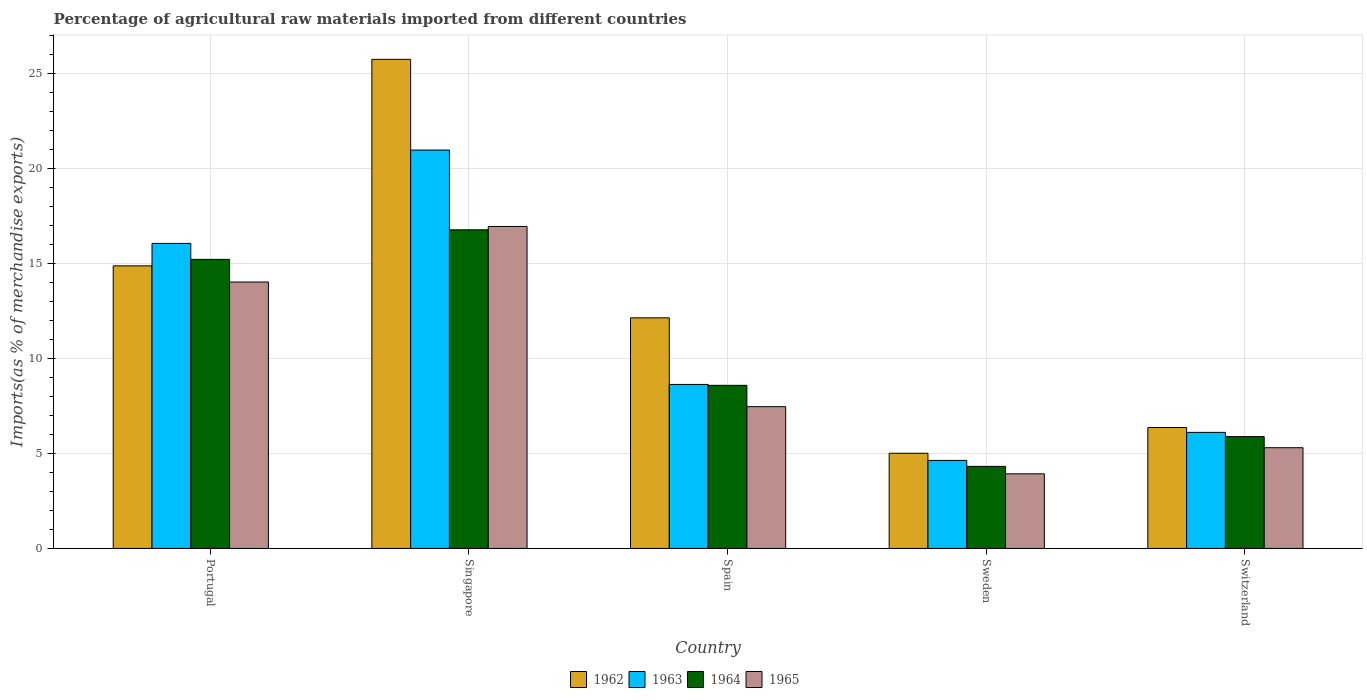How many different coloured bars are there?
Keep it short and to the point. 4. Are the number of bars per tick equal to the number of legend labels?
Your answer should be compact. Yes. How many bars are there on the 2nd tick from the left?
Your response must be concise. 4. What is the percentage of imports to different countries in 1963 in Spain?
Your answer should be very brief. 8.63. Across all countries, what is the maximum percentage of imports to different countries in 1963?
Provide a short and direct response. 20.95. Across all countries, what is the minimum percentage of imports to different countries in 1965?
Make the answer very short. 3.92. In which country was the percentage of imports to different countries in 1965 maximum?
Make the answer very short. Singapore. In which country was the percentage of imports to different countries in 1962 minimum?
Offer a terse response. Sweden. What is the total percentage of imports to different countries in 1962 in the graph?
Your answer should be very brief. 64.08. What is the difference between the percentage of imports to different countries in 1965 in Singapore and that in Switzerland?
Ensure brevity in your answer.  11.64. What is the difference between the percentage of imports to different countries in 1965 in Portugal and the percentage of imports to different countries in 1962 in Switzerland?
Your response must be concise. 7.65. What is the average percentage of imports to different countries in 1963 per country?
Give a very brief answer. 11.27. What is the difference between the percentage of imports to different countries of/in 1962 and percentage of imports to different countries of/in 1963 in Portugal?
Provide a short and direct response. -1.18. In how many countries, is the percentage of imports to different countries in 1965 greater than 15 %?
Offer a very short reply. 1. What is the ratio of the percentage of imports to different countries in 1963 in Singapore to that in Spain?
Make the answer very short. 2.43. Is the percentage of imports to different countries in 1964 in Sweden less than that in Switzerland?
Ensure brevity in your answer.  Yes. Is the difference between the percentage of imports to different countries in 1962 in Singapore and Switzerland greater than the difference between the percentage of imports to different countries in 1963 in Singapore and Switzerland?
Keep it short and to the point. Yes. What is the difference between the highest and the second highest percentage of imports to different countries in 1965?
Provide a succinct answer. 2.92. What is the difference between the highest and the lowest percentage of imports to different countries in 1962?
Keep it short and to the point. 20.72. Is the sum of the percentage of imports to different countries in 1965 in Spain and Sweden greater than the maximum percentage of imports to different countries in 1962 across all countries?
Provide a short and direct response. No. Is it the case that in every country, the sum of the percentage of imports to different countries in 1963 and percentage of imports to different countries in 1962 is greater than the sum of percentage of imports to different countries in 1964 and percentage of imports to different countries in 1965?
Make the answer very short. No. What does the 1st bar from the right in Sweden represents?
Your answer should be very brief. 1965. Are all the bars in the graph horizontal?
Keep it short and to the point. No. What is the difference between two consecutive major ticks on the Y-axis?
Offer a terse response. 5. Does the graph contain any zero values?
Make the answer very short. No. How are the legend labels stacked?
Your answer should be very brief. Horizontal. What is the title of the graph?
Offer a very short reply. Percentage of agricultural raw materials imported from different countries. What is the label or title of the X-axis?
Offer a very short reply. Country. What is the label or title of the Y-axis?
Give a very brief answer. Imports(as % of merchandise exports). What is the Imports(as % of merchandise exports) in 1962 in Portugal?
Provide a short and direct response. 14.86. What is the Imports(as % of merchandise exports) in 1963 in Portugal?
Your answer should be very brief. 16.04. What is the Imports(as % of merchandise exports) of 1964 in Portugal?
Give a very brief answer. 15.2. What is the Imports(as % of merchandise exports) of 1965 in Portugal?
Keep it short and to the point. 14.01. What is the Imports(as % of merchandise exports) in 1962 in Singapore?
Keep it short and to the point. 25.73. What is the Imports(as % of merchandise exports) of 1963 in Singapore?
Ensure brevity in your answer.  20.95. What is the Imports(as % of merchandise exports) in 1964 in Singapore?
Make the answer very short. 16.76. What is the Imports(as % of merchandise exports) in 1965 in Singapore?
Offer a very short reply. 16.93. What is the Imports(as % of merchandise exports) of 1962 in Spain?
Give a very brief answer. 12.13. What is the Imports(as % of merchandise exports) of 1963 in Spain?
Your answer should be compact. 8.63. What is the Imports(as % of merchandise exports) of 1964 in Spain?
Your answer should be compact. 8.58. What is the Imports(as % of merchandise exports) in 1965 in Spain?
Offer a very short reply. 7.46. What is the Imports(as % of merchandise exports) of 1962 in Sweden?
Offer a terse response. 5.01. What is the Imports(as % of merchandise exports) in 1963 in Sweden?
Offer a very short reply. 4.63. What is the Imports(as % of merchandise exports) of 1964 in Sweden?
Provide a succinct answer. 4.32. What is the Imports(as % of merchandise exports) in 1965 in Sweden?
Offer a very short reply. 3.92. What is the Imports(as % of merchandise exports) in 1962 in Switzerland?
Ensure brevity in your answer.  6.36. What is the Imports(as % of merchandise exports) in 1963 in Switzerland?
Offer a very short reply. 6.1. What is the Imports(as % of merchandise exports) in 1964 in Switzerland?
Your answer should be very brief. 5.88. What is the Imports(as % of merchandise exports) of 1965 in Switzerland?
Give a very brief answer. 5.3. Across all countries, what is the maximum Imports(as % of merchandise exports) in 1962?
Keep it short and to the point. 25.73. Across all countries, what is the maximum Imports(as % of merchandise exports) in 1963?
Offer a very short reply. 20.95. Across all countries, what is the maximum Imports(as % of merchandise exports) of 1964?
Provide a short and direct response. 16.76. Across all countries, what is the maximum Imports(as % of merchandise exports) in 1965?
Ensure brevity in your answer.  16.93. Across all countries, what is the minimum Imports(as % of merchandise exports) in 1962?
Provide a short and direct response. 5.01. Across all countries, what is the minimum Imports(as % of merchandise exports) of 1963?
Offer a terse response. 4.63. Across all countries, what is the minimum Imports(as % of merchandise exports) of 1964?
Offer a very short reply. 4.32. Across all countries, what is the minimum Imports(as % of merchandise exports) of 1965?
Your answer should be compact. 3.92. What is the total Imports(as % of merchandise exports) of 1962 in the graph?
Offer a very short reply. 64.08. What is the total Imports(as % of merchandise exports) in 1963 in the graph?
Provide a short and direct response. 56.36. What is the total Imports(as % of merchandise exports) of 1964 in the graph?
Provide a succinct answer. 50.74. What is the total Imports(as % of merchandise exports) in 1965 in the graph?
Ensure brevity in your answer.  47.63. What is the difference between the Imports(as % of merchandise exports) of 1962 in Portugal and that in Singapore?
Your answer should be very brief. -10.86. What is the difference between the Imports(as % of merchandise exports) in 1963 in Portugal and that in Singapore?
Offer a very short reply. -4.91. What is the difference between the Imports(as % of merchandise exports) in 1964 in Portugal and that in Singapore?
Offer a terse response. -1.55. What is the difference between the Imports(as % of merchandise exports) of 1965 in Portugal and that in Singapore?
Your answer should be very brief. -2.92. What is the difference between the Imports(as % of merchandise exports) in 1962 in Portugal and that in Spain?
Your answer should be very brief. 2.73. What is the difference between the Imports(as % of merchandise exports) in 1963 in Portugal and that in Spain?
Make the answer very short. 7.42. What is the difference between the Imports(as % of merchandise exports) of 1964 in Portugal and that in Spain?
Ensure brevity in your answer.  6.63. What is the difference between the Imports(as % of merchandise exports) of 1965 in Portugal and that in Spain?
Your response must be concise. 6.56. What is the difference between the Imports(as % of merchandise exports) of 1962 in Portugal and that in Sweden?
Keep it short and to the point. 9.86. What is the difference between the Imports(as % of merchandise exports) in 1963 in Portugal and that in Sweden?
Ensure brevity in your answer.  11.41. What is the difference between the Imports(as % of merchandise exports) of 1964 in Portugal and that in Sweden?
Offer a terse response. 10.89. What is the difference between the Imports(as % of merchandise exports) in 1965 in Portugal and that in Sweden?
Your answer should be very brief. 10.09. What is the difference between the Imports(as % of merchandise exports) in 1962 in Portugal and that in Switzerland?
Ensure brevity in your answer.  8.5. What is the difference between the Imports(as % of merchandise exports) in 1963 in Portugal and that in Switzerland?
Your response must be concise. 9.94. What is the difference between the Imports(as % of merchandise exports) in 1964 in Portugal and that in Switzerland?
Offer a very short reply. 9.32. What is the difference between the Imports(as % of merchandise exports) of 1965 in Portugal and that in Switzerland?
Provide a short and direct response. 8.72. What is the difference between the Imports(as % of merchandise exports) of 1962 in Singapore and that in Spain?
Ensure brevity in your answer.  13.6. What is the difference between the Imports(as % of merchandise exports) in 1963 in Singapore and that in Spain?
Provide a short and direct response. 12.33. What is the difference between the Imports(as % of merchandise exports) of 1964 in Singapore and that in Spain?
Your response must be concise. 8.18. What is the difference between the Imports(as % of merchandise exports) in 1965 in Singapore and that in Spain?
Ensure brevity in your answer.  9.48. What is the difference between the Imports(as % of merchandise exports) in 1962 in Singapore and that in Sweden?
Provide a succinct answer. 20.72. What is the difference between the Imports(as % of merchandise exports) in 1963 in Singapore and that in Sweden?
Provide a succinct answer. 16.32. What is the difference between the Imports(as % of merchandise exports) in 1964 in Singapore and that in Sweden?
Keep it short and to the point. 12.44. What is the difference between the Imports(as % of merchandise exports) of 1965 in Singapore and that in Sweden?
Your answer should be compact. 13.01. What is the difference between the Imports(as % of merchandise exports) in 1962 in Singapore and that in Switzerland?
Offer a very short reply. 19.37. What is the difference between the Imports(as % of merchandise exports) in 1963 in Singapore and that in Switzerland?
Your response must be concise. 14.85. What is the difference between the Imports(as % of merchandise exports) in 1964 in Singapore and that in Switzerland?
Ensure brevity in your answer.  10.88. What is the difference between the Imports(as % of merchandise exports) of 1965 in Singapore and that in Switzerland?
Provide a succinct answer. 11.64. What is the difference between the Imports(as % of merchandise exports) in 1962 in Spain and that in Sweden?
Provide a succinct answer. 7.12. What is the difference between the Imports(as % of merchandise exports) of 1963 in Spain and that in Sweden?
Make the answer very short. 4. What is the difference between the Imports(as % of merchandise exports) in 1964 in Spain and that in Sweden?
Your response must be concise. 4.26. What is the difference between the Imports(as % of merchandise exports) of 1965 in Spain and that in Sweden?
Provide a short and direct response. 3.53. What is the difference between the Imports(as % of merchandise exports) of 1962 in Spain and that in Switzerland?
Give a very brief answer. 5.77. What is the difference between the Imports(as % of merchandise exports) in 1963 in Spain and that in Switzerland?
Offer a very short reply. 2.52. What is the difference between the Imports(as % of merchandise exports) of 1964 in Spain and that in Switzerland?
Your answer should be compact. 2.7. What is the difference between the Imports(as % of merchandise exports) of 1965 in Spain and that in Switzerland?
Ensure brevity in your answer.  2.16. What is the difference between the Imports(as % of merchandise exports) of 1962 in Sweden and that in Switzerland?
Offer a very short reply. -1.35. What is the difference between the Imports(as % of merchandise exports) of 1963 in Sweden and that in Switzerland?
Keep it short and to the point. -1.47. What is the difference between the Imports(as % of merchandise exports) of 1964 in Sweden and that in Switzerland?
Your answer should be very brief. -1.57. What is the difference between the Imports(as % of merchandise exports) of 1965 in Sweden and that in Switzerland?
Give a very brief answer. -1.37. What is the difference between the Imports(as % of merchandise exports) of 1962 in Portugal and the Imports(as % of merchandise exports) of 1963 in Singapore?
Ensure brevity in your answer.  -6.09. What is the difference between the Imports(as % of merchandise exports) of 1962 in Portugal and the Imports(as % of merchandise exports) of 1964 in Singapore?
Offer a very short reply. -1.9. What is the difference between the Imports(as % of merchandise exports) of 1962 in Portugal and the Imports(as % of merchandise exports) of 1965 in Singapore?
Your answer should be compact. -2.07. What is the difference between the Imports(as % of merchandise exports) in 1963 in Portugal and the Imports(as % of merchandise exports) in 1964 in Singapore?
Provide a short and direct response. -0.72. What is the difference between the Imports(as % of merchandise exports) in 1963 in Portugal and the Imports(as % of merchandise exports) in 1965 in Singapore?
Your answer should be compact. -0.89. What is the difference between the Imports(as % of merchandise exports) of 1964 in Portugal and the Imports(as % of merchandise exports) of 1965 in Singapore?
Ensure brevity in your answer.  -1.73. What is the difference between the Imports(as % of merchandise exports) of 1962 in Portugal and the Imports(as % of merchandise exports) of 1963 in Spain?
Your response must be concise. 6.24. What is the difference between the Imports(as % of merchandise exports) in 1962 in Portugal and the Imports(as % of merchandise exports) in 1964 in Spain?
Ensure brevity in your answer.  6.28. What is the difference between the Imports(as % of merchandise exports) in 1962 in Portugal and the Imports(as % of merchandise exports) in 1965 in Spain?
Keep it short and to the point. 7.41. What is the difference between the Imports(as % of merchandise exports) in 1963 in Portugal and the Imports(as % of merchandise exports) in 1964 in Spain?
Provide a succinct answer. 7.47. What is the difference between the Imports(as % of merchandise exports) in 1963 in Portugal and the Imports(as % of merchandise exports) in 1965 in Spain?
Your answer should be very brief. 8.59. What is the difference between the Imports(as % of merchandise exports) in 1964 in Portugal and the Imports(as % of merchandise exports) in 1965 in Spain?
Offer a terse response. 7.75. What is the difference between the Imports(as % of merchandise exports) in 1962 in Portugal and the Imports(as % of merchandise exports) in 1963 in Sweden?
Offer a very short reply. 10.23. What is the difference between the Imports(as % of merchandise exports) of 1962 in Portugal and the Imports(as % of merchandise exports) of 1964 in Sweden?
Provide a succinct answer. 10.55. What is the difference between the Imports(as % of merchandise exports) in 1962 in Portugal and the Imports(as % of merchandise exports) in 1965 in Sweden?
Make the answer very short. 10.94. What is the difference between the Imports(as % of merchandise exports) of 1963 in Portugal and the Imports(as % of merchandise exports) of 1964 in Sweden?
Offer a very short reply. 11.73. What is the difference between the Imports(as % of merchandise exports) in 1963 in Portugal and the Imports(as % of merchandise exports) in 1965 in Sweden?
Ensure brevity in your answer.  12.12. What is the difference between the Imports(as % of merchandise exports) in 1964 in Portugal and the Imports(as % of merchandise exports) in 1965 in Sweden?
Offer a terse response. 11.28. What is the difference between the Imports(as % of merchandise exports) in 1962 in Portugal and the Imports(as % of merchandise exports) in 1963 in Switzerland?
Offer a terse response. 8.76. What is the difference between the Imports(as % of merchandise exports) in 1962 in Portugal and the Imports(as % of merchandise exports) in 1964 in Switzerland?
Offer a terse response. 8.98. What is the difference between the Imports(as % of merchandise exports) of 1962 in Portugal and the Imports(as % of merchandise exports) of 1965 in Switzerland?
Provide a succinct answer. 9.57. What is the difference between the Imports(as % of merchandise exports) in 1963 in Portugal and the Imports(as % of merchandise exports) in 1964 in Switzerland?
Offer a terse response. 10.16. What is the difference between the Imports(as % of merchandise exports) in 1963 in Portugal and the Imports(as % of merchandise exports) in 1965 in Switzerland?
Make the answer very short. 10.75. What is the difference between the Imports(as % of merchandise exports) in 1964 in Portugal and the Imports(as % of merchandise exports) in 1965 in Switzerland?
Ensure brevity in your answer.  9.91. What is the difference between the Imports(as % of merchandise exports) of 1962 in Singapore and the Imports(as % of merchandise exports) of 1963 in Spain?
Ensure brevity in your answer.  17.1. What is the difference between the Imports(as % of merchandise exports) in 1962 in Singapore and the Imports(as % of merchandise exports) in 1964 in Spain?
Give a very brief answer. 17.15. What is the difference between the Imports(as % of merchandise exports) of 1962 in Singapore and the Imports(as % of merchandise exports) of 1965 in Spain?
Provide a short and direct response. 18.27. What is the difference between the Imports(as % of merchandise exports) in 1963 in Singapore and the Imports(as % of merchandise exports) in 1964 in Spain?
Your response must be concise. 12.38. What is the difference between the Imports(as % of merchandise exports) in 1963 in Singapore and the Imports(as % of merchandise exports) in 1965 in Spain?
Give a very brief answer. 13.5. What is the difference between the Imports(as % of merchandise exports) of 1964 in Singapore and the Imports(as % of merchandise exports) of 1965 in Spain?
Provide a succinct answer. 9.3. What is the difference between the Imports(as % of merchandise exports) in 1962 in Singapore and the Imports(as % of merchandise exports) in 1963 in Sweden?
Provide a short and direct response. 21.09. What is the difference between the Imports(as % of merchandise exports) of 1962 in Singapore and the Imports(as % of merchandise exports) of 1964 in Sweden?
Make the answer very short. 21.41. What is the difference between the Imports(as % of merchandise exports) of 1962 in Singapore and the Imports(as % of merchandise exports) of 1965 in Sweden?
Your answer should be compact. 21.8. What is the difference between the Imports(as % of merchandise exports) of 1963 in Singapore and the Imports(as % of merchandise exports) of 1964 in Sweden?
Your response must be concise. 16.64. What is the difference between the Imports(as % of merchandise exports) in 1963 in Singapore and the Imports(as % of merchandise exports) in 1965 in Sweden?
Offer a very short reply. 17.03. What is the difference between the Imports(as % of merchandise exports) in 1964 in Singapore and the Imports(as % of merchandise exports) in 1965 in Sweden?
Your response must be concise. 12.83. What is the difference between the Imports(as % of merchandise exports) of 1962 in Singapore and the Imports(as % of merchandise exports) of 1963 in Switzerland?
Your answer should be compact. 19.62. What is the difference between the Imports(as % of merchandise exports) in 1962 in Singapore and the Imports(as % of merchandise exports) in 1964 in Switzerland?
Ensure brevity in your answer.  19.84. What is the difference between the Imports(as % of merchandise exports) of 1962 in Singapore and the Imports(as % of merchandise exports) of 1965 in Switzerland?
Ensure brevity in your answer.  20.43. What is the difference between the Imports(as % of merchandise exports) in 1963 in Singapore and the Imports(as % of merchandise exports) in 1964 in Switzerland?
Provide a succinct answer. 15.07. What is the difference between the Imports(as % of merchandise exports) in 1963 in Singapore and the Imports(as % of merchandise exports) in 1965 in Switzerland?
Keep it short and to the point. 15.66. What is the difference between the Imports(as % of merchandise exports) in 1964 in Singapore and the Imports(as % of merchandise exports) in 1965 in Switzerland?
Your response must be concise. 11.46. What is the difference between the Imports(as % of merchandise exports) in 1962 in Spain and the Imports(as % of merchandise exports) in 1963 in Sweden?
Offer a very short reply. 7.5. What is the difference between the Imports(as % of merchandise exports) in 1962 in Spain and the Imports(as % of merchandise exports) in 1964 in Sweden?
Your answer should be compact. 7.81. What is the difference between the Imports(as % of merchandise exports) in 1962 in Spain and the Imports(as % of merchandise exports) in 1965 in Sweden?
Your answer should be compact. 8.21. What is the difference between the Imports(as % of merchandise exports) in 1963 in Spain and the Imports(as % of merchandise exports) in 1964 in Sweden?
Your answer should be compact. 4.31. What is the difference between the Imports(as % of merchandise exports) in 1963 in Spain and the Imports(as % of merchandise exports) in 1965 in Sweden?
Offer a terse response. 4.7. What is the difference between the Imports(as % of merchandise exports) of 1964 in Spain and the Imports(as % of merchandise exports) of 1965 in Sweden?
Your answer should be very brief. 4.65. What is the difference between the Imports(as % of merchandise exports) of 1962 in Spain and the Imports(as % of merchandise exports) of 1963 in Switzerland?
Provide a succinct answer. 6.02. What is the difference between the Imports(as % of merchandise exports) of 1962 in Spain and the Imports(as % of merchandise exports) of 1964 in Switzerland?
Give a very brief answer. 6.25. What is the difference between the Imports(as % of merchandise exports) of 1962 in Spain and the Imports(as % of merchandise exports) of 1965 in Switzerland?
Your answer should be very brief. 6.83. What is the difference between the Imports(as % of merchandise exports) of 1963 in Spain and the Imports(as % of merchandise exports) of 1964 in Switzerland?
Keep it short and to the point. 2.74. What is the difference between the Imports(as % of merchandise exports) in 1963 in Spain and the Imports(as % of merchandise exports) in 1965 in Switzerland?
Provide a short and direct response. 3.33. What is the difference between the Imports(as % of merchandise exports) of 1964 in Spain and the Imports(as % of merchandise exports) of 1965 in Switzerland?
Provide a short and direct response. 3.28. What is the difference between the Imports(as % of merchandise exports) of 1962 in Sweden and the Imports(as % of merchandise exports) of 1963 in Switzerland?
Offer a very short reply. -1.1. What is the difference between the Imports(as % of merchandise exports) in 1962 in Sweden and the Imports(as % of merchandise exports) in 1964 in Switzerland?
Offer a very short reply. -0.88. What is the difference between the Imports(as % of merchandise exports) in 1962 in Sweden and the Imports(as % of merchandise exports) in 1965 in Switzerland?
Ensure brevity in your answer.  -0.29. What is the difference between the Imports(as % of merchandise exports) of 1963 in Sweden and the Imports(as % of merchandise exports) of 1964 in Switzerland?
Give a very brief answer. -1.25. What is the difference between the Imports(as % of merchandise exports) in 1963 in Sweden and the Imports(as % of merchandise exports) in 1965 in Switzerland?
Your answer should be compact. -0.67. What is the difference between the Imports(as % of merchandise exports) of 1964 in Sweden and the Imports(as % of merchandise exports) of 1965 in Switzerland?
Your answer should be very brief. -0.98. What is the average Imports(as % of merchandise exports) of 1962 per country?
Provide a short and direct response. 12.82. What is the average Imports(as % of merchandise exports) in 1963 per country?
Your response must be concise. 11.27. What is the average Imports(as % of merchandise exports) in 1964 per country?
Provide a succinct answer. 10.15. What is the average Imports(as % of merchandise exports) of 1965 per country?
Your answer should be compact. 9.53. What is the difference between the Imports(as % of merchandise exports) of 1962 and Imports(as % of merchandise exports) of 1963 in Portugal?
Offer a very short reply. -1.18. What is the difference between the Imports(as % of merchandise exports) in 1962 and Imports(as % of merchandise exports) in 1964 in Portugal?
Offer a terse response. -0.34. What is the difference between the Imports(as % of merchandise exports) in 1962 and Imports(as % of merchandise exports) in 1965 in Portugal?
Offer a terse response. 0.85. What is the difference between the Imports(as % of merchandise exports) in 1963 and Imports(as % of merchandise exports) in 1964 in Portugal?
Your answer should be compact. 0.84. What is the difference between the Imports(as % of merchandise exports) of 1963 and Imports(as % of merchandise exports) of 1965 in Portugal?
Offer a very short reply. 2.03. What is the difference between the Imports(as % of merchandise exports) of 1964 and Imports(as % of merchandise exports) of 1965 in Portugal?
Offer a very short reply. 1.19. What is the difference between the Imports(as % of merchandise exports) in 1962 and Imports(as % of merchandise exports) in 1963 in Singapore?
Ensure brevity in your answer.  4.77. What is the difference between the Imports(as % of merchandise exports) in 1962 and Imports(as % of merchandise exports) in 1964 in Singapore?
Provide a succinct answer. 8.97. What is the difference between the Imports(as % of merchandise exports) of 1962 and Imports(as % of merchandise exports) of 1965 in Singapore?
Your answer should be very brief. 8.79. What is the difference between the Imports(as % of merchandise exports) in 1963 and Imports(as % of merchandise exports) in 1964 in Singapore?
Offer a very short reply. 4.19. What is the difference between the Imports(as % of merchandise exports) of 1963 and Imports(as % of merchandise exports) of 1965 in Singapore?
Give a very brief answer. 4.02. What is the difference between the Imports(as % of merchandise exports) of 1964 and Imports(as % of merchandise exports) of 1965 in Singapore?
Keep it short and to the point. -0.18. What is the difference between the Imports(as % of merchandise exports) of 1962 and Imports(as % of merchandise exports) of 1963 in Spain?
Make the answer very short. 3.5. What is the difference between the Imports(as % of merchandise exports) of 1962 and Imports(as % of merchandise exports) of 1964 in Spain?
Keep it short and to the point. 3.55. What is the difference between the Imports(as % of merchandise exports) in 1962 and Imports(as % of merchandise exports) in 1965 in Spain?
Make the answer very short. 4.67. What is the difference between the Imports(as % of merchandise exports) in 1963 and Imports(as % of merchandise exports) in 1964 in Spain?
Provide a short and direct response. 0.05. What is the difference between the Imports(as % of merchandise exports) in 1963 and Imports(as % of merchandise exports) in 1965 in Spain?
Provide a short and direct response. 1.17. What is the difference between the Imports(as % of merchandise exports) in 1964 and Imports(as % of merchandise exports) in 1965 in Spain?
Offer a very short reply. 1.12. What is the difference between the Imports(as % of merchandise exports) of 1962 and Imports(as % of merchandise exports) of 1963 in Sweden?
Your answer should be compact. 0.38. What is the difference between the Imports(as % of merchandise exports) in 1962 and Imports(as % of merchandise exports) in 1964 in Sweden?
Make the answer very short. 0.69. What is the difference between the Imports(as % of merchandise exports) of 1962 and Imports(as % of merchandise exports) of 1965 in Sweden?
Provide a short and direct response. 1.08. What is the difference between the Imports(as % of merchandise exports) of 1963 and Imports(as % of merchandise exports) of 1964 in Sweden?
Offer a very short reply. 0.31. What is the difference between the Imports(as % of merchandise exports) in 1963 and Imports(as % of merchandise exports) in 1965 in Sweden?
Keep it short and to the point. 0.71. What is the difference between the Imports(as % of merchandise exports) in 1964 and Imports(as % of merchandise exports) in 1965 in Sweden?
Offer a very short reply. 0.39. What is the difference between the Imports(as % of merchandise exports) in 1962 and Imports(as % of merchandise exports) in 1963 in Switzerland?
Keep it short and to the point. 0.26. What is the difference between the Imports(as % of merchandise exports) in 1962 and Imports(as % of merchandise exports) in 1964 in Switzerland?
Offer a very short reply. 0.48. What is the difference between the Imports(as % of merchandise exports) in 1962 and Imports(as % of merchandise exports) in 1965 in Switzerland?
Your answer should be very brief. 1.06. What is the difference between the Imports(as % of merchandise exports) of 1963 and Imports(as % of merchandise exports) of 1964 in Switzerland?
Your answer should be very brief. 0.22. What is the difference between the Imports(as % of merchandise exports) in 1963 and Imports(as % of merchandise exports) in 1965 in Switzerland?
Your response must be concise. 0.81. What is the difference between the Imports(as % of merchandise exports) in 1964 and Imports(as % of merchandise exports) in 1965 in Switzerland?
Ensure brevity in your answer.  0.58. What is the ratio of the Imports(as % of merchandise exports) in 1962 in Portugal to that in Singapore?
Provide a succinct answer. 0.58. What is the ratio of the Imports(as % of merchandise exports) in 1963 in Portugal to that in Singapore?
Offer a very short reply. 0.77. What is the ratio of the Imports(as % of merchandise exports) of 1964 in Portugal to that in Singapore?
Offer a terse response. 0.91. What is the ratio of the Imports(as % of merchandise exports) of 1965 in Portugal to that in Singapore?
Keep it short and to the point. 0.83. What is the ratio of the Imports(as % of merchandise exports) of 1962 in Portugal to that in Spain?
Make the answer very short. 1.23. What is the ratio of the Imports(as % of merchandise exports) in 1963 in Portugal to that in Spain?
Ensure brevity in your answer.  1.86. What is the ratio of the Imports(as % of merchandise exports) in 1964 in Portugal to that in Spain?
Provide a short and direct response. 1.77. What is the ratio of the Imports(as % of merchandise exports) in 1965 in Portugal to that in Spain?
Your answer should be compact. 1.88. What is the ratio of the Imports(as % of merchandise exports) of 1962 in Portugal to that in Sweden?
Give a very brief answer. 2.97. What is the ratio of the Imports(as % of merchandise exports) in 1963 in Portugal to that in Sweden?
Give a very brief answer. 3.46. What is the ratio of the Imports(as % of merchandise exports) in 1964 in Portugal to that in Sweden?
Provide a succinct answer. 3.52. What is the ratio of the Imports(as % of merchandise exports) of 1965 in Portugal to that in Sweden?
Your response must be concise. 3.57. What is the ratio of the Imports(as % of merchandise exports) in 1962 in Portugal to that in Switzerland?
Make the answer very short. 2.34. What is the ratio of the Imports(as % of merchandise exports) of 1963 in Portugal to that in Switzerland?
Ensure brevity in your answer.  2.63. What is the ratio of the Imports(as % of merchandise exports) of 1964 in Portugal to that in Switzerland?
Your answer should be very brief. 2.58. What is the ratio of the Imports(as % of merchandise exports) of 1965 in Portugal to that in Switzerland?
Keep it short and to the point. 2.65. What is the ratio of the Imports(as % of merchandise exports) in 1962 in Singapore to that in Spain?
Offer a terse response. 2.12. What is the ratio of the Imports(as % of merchandise exports) of 1963 in Singapore to that in Spain?
Your answer should be very brief. 2.43. What is the ratio of the Imports(as % of merchandise exports) of 1964 in Singapore to that in Spain?
Make the answer very short. 1.95. What is the ratio of the Imports(as % of merchandise exports) of 1965 in Singapore to that in Spain?
Keep it short and to the point. 2.27. What is the ratio of the Imports(as % of merchandise exports) in 1962 in Singapore to that in Sweden?
Your answer should be compact. 5.14. What is the ratio of the Imports(as % of merchandise exports) of 1963 in Singapore to that in Sweden?
Provide a short and direct response. 4.53. What is the ratio of the Imports(as % of merchandise exports) of 1964 in Singapore to that in Sweden?
Your answer should be compact. 3.88. What is the ratio of the Imports(as % of merchandise exports) in 1965 in Singapore to that in Sweden?
Keep it short and to the point. 4.32. What is the ratio of the Imports(as % of merchandise exports) of 1962 in Singapore to that in Switzerland?
Offer a terse response. 4.04. What is the ratio of the Imports(as % of merchandise exports) in 1963 in Singapore to that in Switzerland?
Offer a very short reply. 3.43. What is the ratio of the Imports(as % of merchandise exports) of 1964 in Singapore to that in Switzerland?
Ensure brevity in your answer.  2.85. What is the ratio of the Imports(as % of merchandise exports) in 1965 in Singapore to that in Switzerland?
Offer a very short reply. 3.2. What is the ratio of the Imports(as % of merchandise exports) in 1962 in Spain to that in Sweden?
Provide a succinct answer. 2.42. What is the ratio of the Imports(as % of merchandise exports) of 1963 in Spain to that in Sweden?
Provide a succinct answer. 1.86. What is the ratio of the Imports(as % of merchandise exports) in 1964 in Spain to that in Sweden?
Make the answer very short. 1.99. What is the ratio of the Imports(as % of merchandise exports) of 1965 in Spain to that in Sweden?
Provide a succinct answer. 1.9. What is the ratio of the Imports(as % of merchandise exports) of 1962 in Spain to that in Switzerland?
Keep it short and to the point. 1.91. What is the ratio of the Imports(as % of merchandise exports) of 1963 in Spain to that in Switzerland?
Keep it short and to the point. 1.41. What is the ratio of the Imports(as % of merchandise exports) of 1964 in Spain to that in Switzerland?
Offer a very short reply. 1.46. What is the ratio of the Imports(as % of merchandise exports) of 1965 in Spain to that in Switzerland?
Make the answer very short. 1.41. What is the ratio of the Imports(as % of merchandise exports) of 1962 in Sweden to that in Switzerland?
Provide a short and direct response. 0.79. What is the ratio of the Imports(as % of merchandise exports) of 1963 in Sweden to that in Switzerland?
Keep it short and to the point. 0.76. What is the ratio of the Imports(as % of merchandise exports) in 1964 in Sweden to that in Switzerland?
Your answer should be compact. 0.73. What is the ratio of the Imports(as % of merchandise exports) in 1965 in Sweden to that in Switzerland?
Give a very brief answer. 0.74. What is the difference between the highest and the second highest Imports(as % of merchandise exports) of 1962?
Ensure brevity in your answer.  10.86. What is the difference between the highest and the second highest Imports(as % of merchandise exports) of 1963?
Your response must be concise. 4.91. What is the difference between the highest and the second highest Imports(as % of merchandise exports) of 1964?
Ensure brevity in your answer.  1.55. What is the difference between the highest and the second highest Imports(as % of merchandise exports) of 1965?
Ensure brevity in your answer.  2.92. What is the difference between the highest and the lowest Imports(as % of merchandise exports) in 1962?
Your answer should be compact. 20.72. What is the difference between the highest and the lowest Imports(as % of merchandise exports) in 1963?
Offer a very short reply. 16.32. What is the difference between the highest and the lowest Imports(as % of merchandise exports) in 1964?
Ensure brevity in your answer.  12.44. What is the difference between the highest and the lowest Imports(as % of merchandise exports) of 1965?
Give a very brief answer. 13.01. 